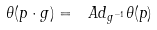Convert formula to latex. <formula><loc_0><loc_0><loc_500><loc_500>\theta ( p \cdot g ) = \ A d _ { g ^ { - 1 } } \theta ( p )</formula> 